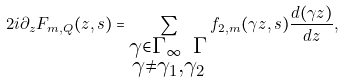Convert formula to latex. <formula><loc_0><loc_0><loc_500><loc_500>2 i \partial _ { z } F _ { m , Q } ( z , s ) = \sum _ { \substack { \gamma \in \Gamma _ { \infty } \ \Gamma \\ \gamma \neq \gamma _ { 1 } , \gamma _ { 2 } } } f _ { 2 , m } ( \gamma z , s ) \frac { d ( \gamma z ) } { d z } ,</formula> 